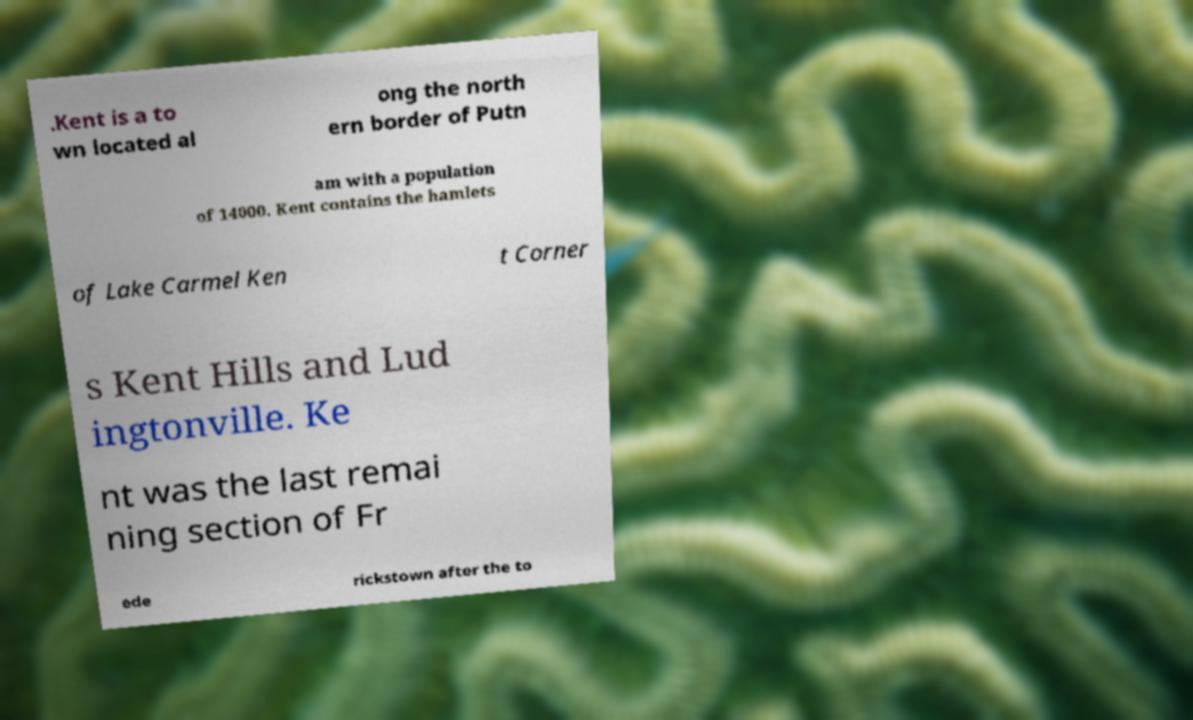Please identify and transcribe the text found in this image. .Kent is a to wn located al ong the north ern border of Putn am with a population of 14000. Kent contains the hamlets of Lake Carmel Ken t Corner s Kent Hills and Lud ingtonville. Ke nt was the last remai ning section of Fr ede rickstown after the to 